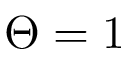<formula> <loc_0><loc_0><loc_500><loc_500>\Theta = 1</formula> 